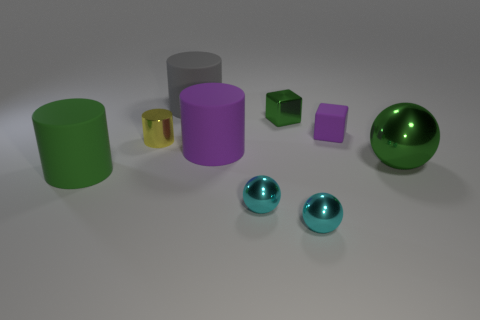There is a shiny block; is it the same color as the big cylinder behind the big purple matte object?
Make the answer very short. No. There is a sphere that is behind the large green thing that is on the left side of the large object that is behind the large purple rubber object; how big is it?
Make the answer very short. Large. How many cylinders have the same color as the big shiny object?
Keep it short and to the point. 1. How many things are spheres or cyan objects that are in front of the green shiny block?
Offer a terse response. 3. The large shiny thing is what color?
Offer a terse response. Green. The tiny cube that is behind the tiny rubber object is what color?
Your answer should be very brief. Green. What number of tiny cyan metallic things are behind the green metal object in front of the purple matte block?
Give a very brief answer. 0. Does the yellow metallic thing have the same size as the green thing that is on the left side of the big purple object?
Keep it short and to the point. No. Are there any other gray cylinders that have the same size as the shiny cylinder?
Ensure brevity in your answer.  No. How many things are either big blue objects or big green metallic balls?
Provide a short and direct response. 1. 